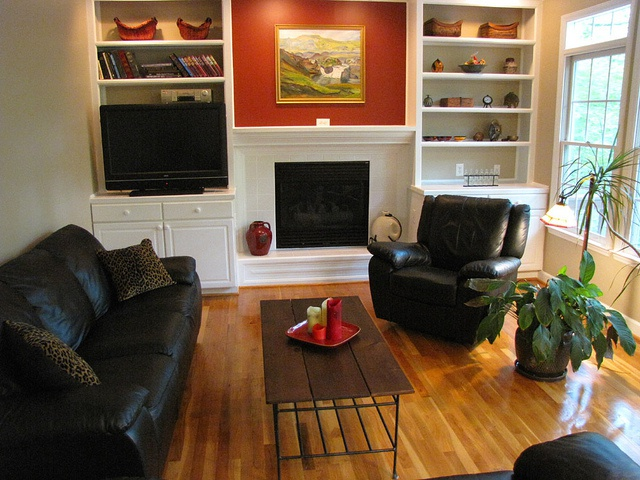Describe the objects in this image and their specific colors. I can see couch in gray, black, darkgreen, blue, and darkblue tones, couch in gray, black, and blue tones, couch in gray and black tones, chair in gray and black tones, and potted plant in gray, black, darkgreen, and teal tones in this image. 